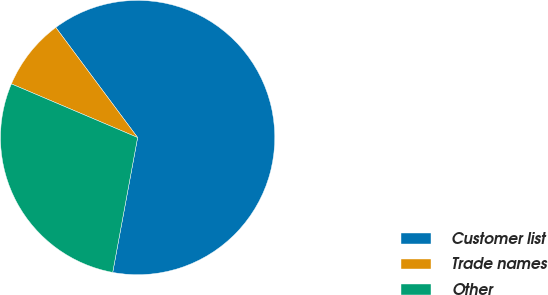Convert chart. <chart><loc_0><loc_0><loc_500><loc_500><pie_chart><fcel>Customer list<fcel>Trade names<fcel>Other<nl><fcel>63.08%<fcel>8.43%<fcel>28.49%<nl></chart> 